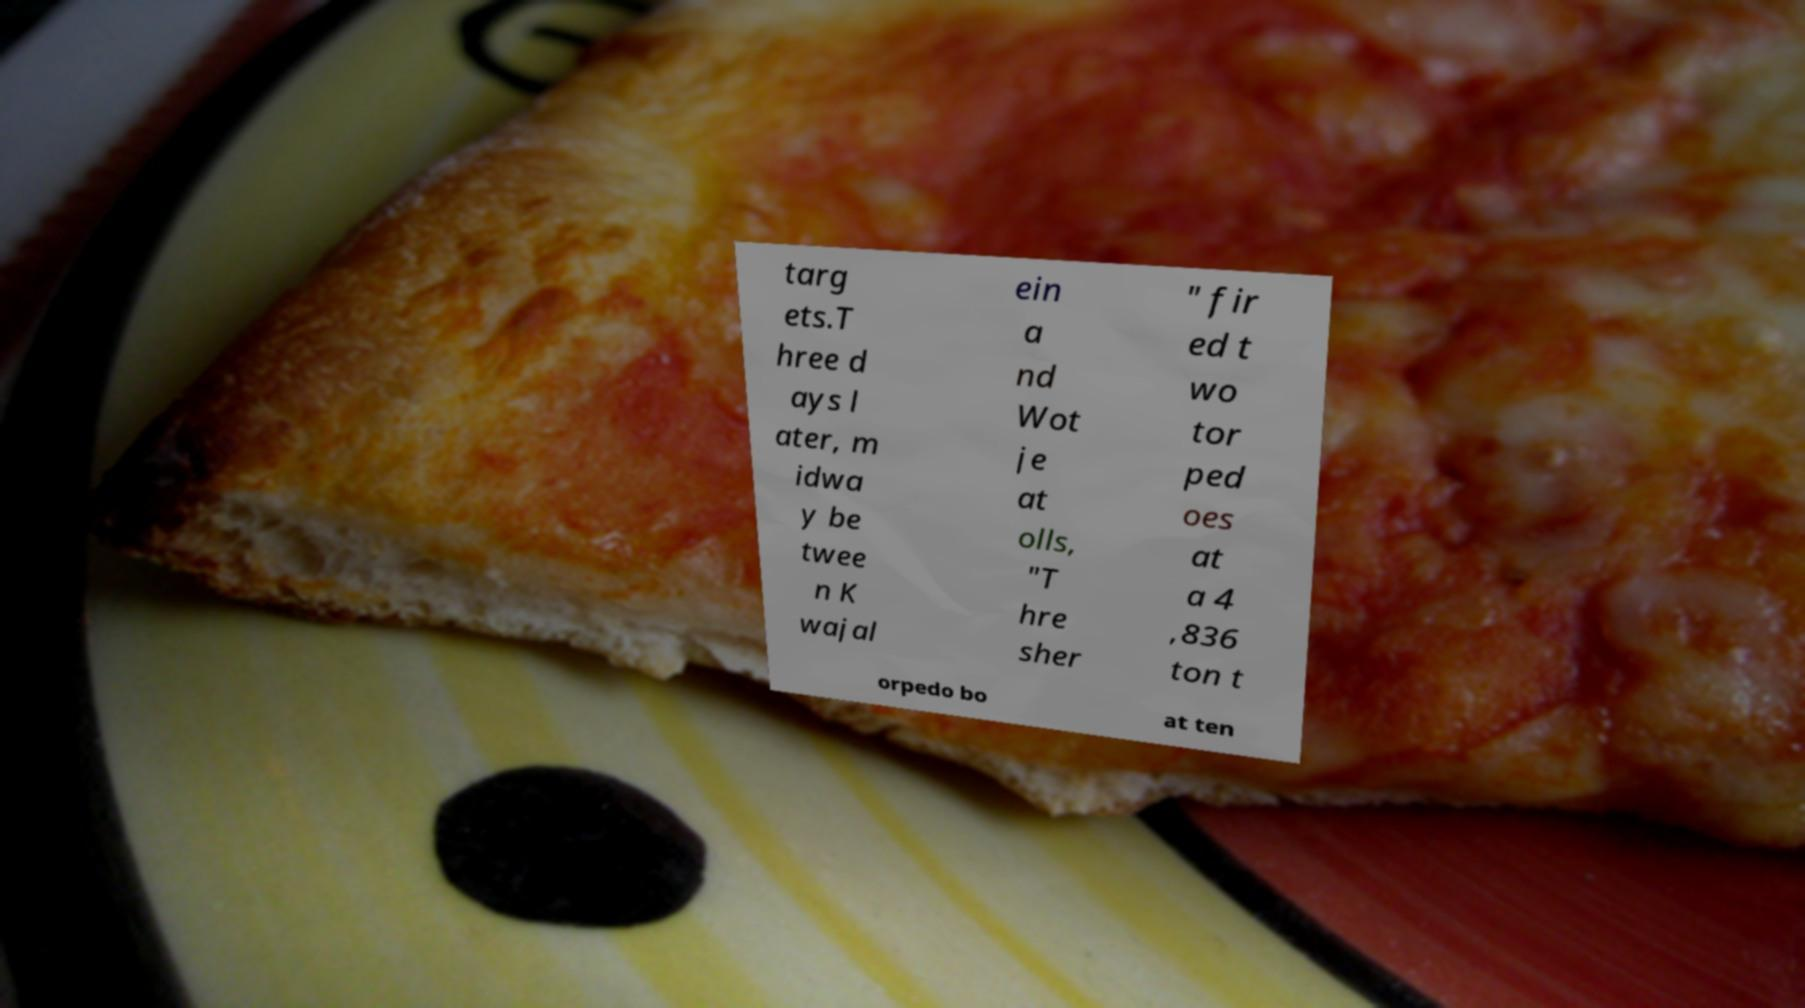Can you accurately transcribe the text from the provided image for me? targ ets.T hree d ays l ater, m idwa y be twee n K wajal ein a nd Wot je at olls, "T hre sher " fir ed t wo tor ped oes at a 4 ,836 ton t orpedo bo at ten 